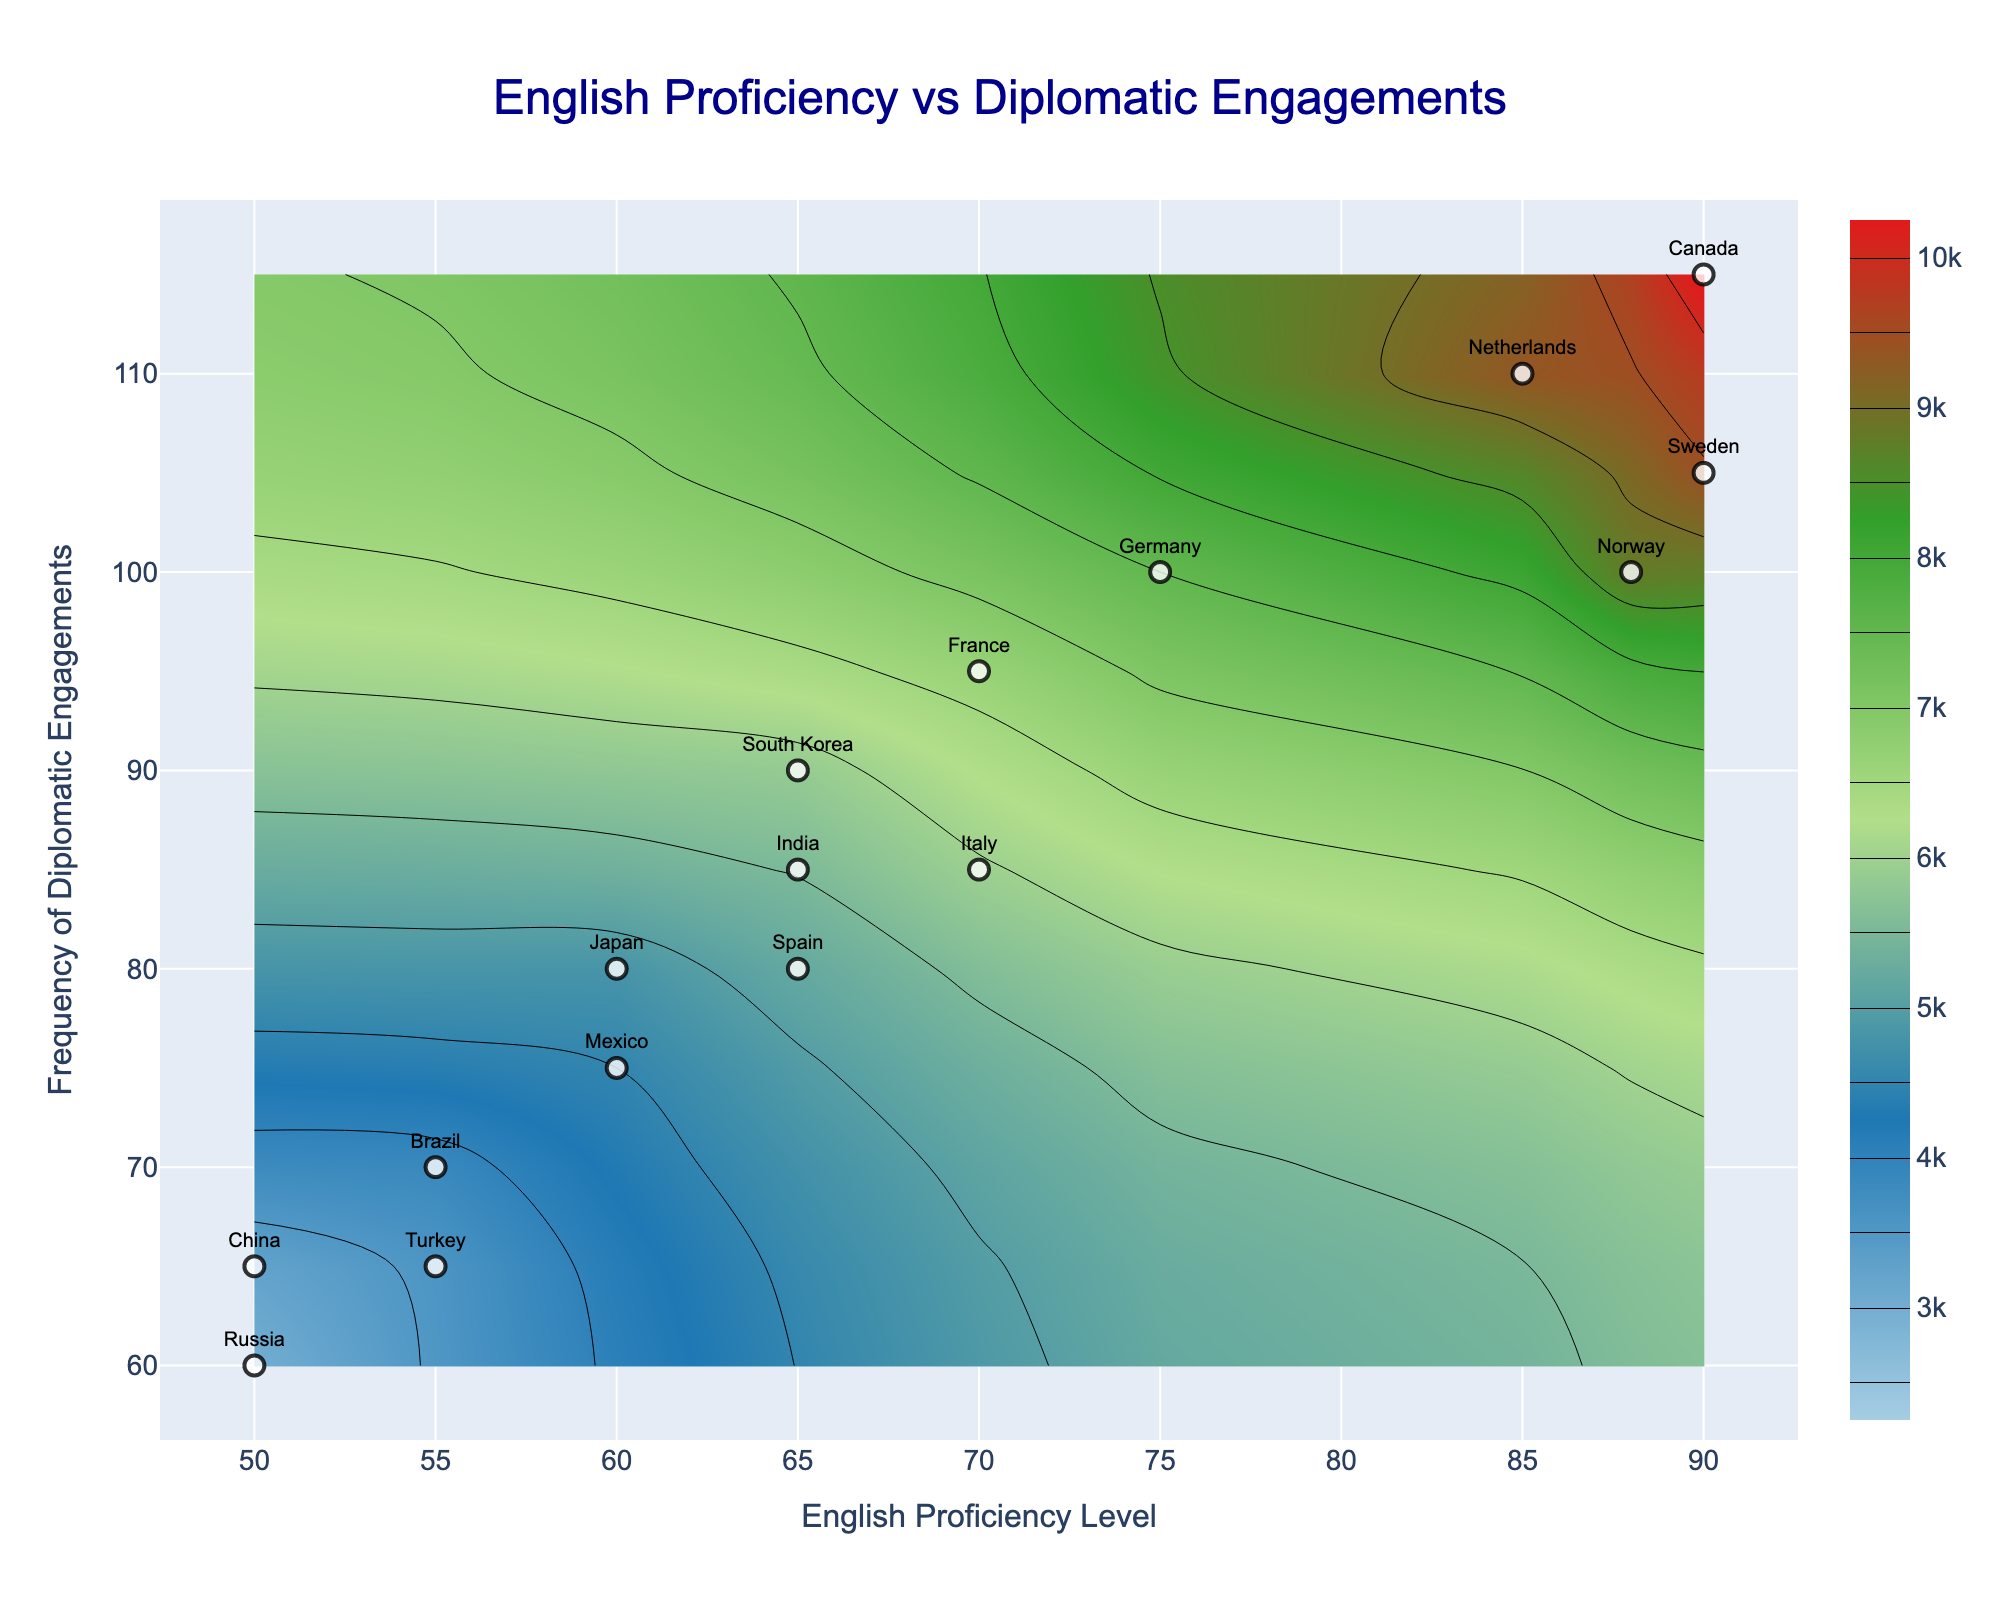What is the title of the plot? The title of the plot is prominently displayed at the top center of the figure. It reads "English Proficiency vs Diplomatic Engagements".
Answer: English Proficiency vs Diplomatic Engagements What are the labels of the x and y axes? The x-axis is labeled as "English Proficiency Level" and the y-axis is labeled as "Frequency of Diplomatic Engagements".
Answer: English Proficiency Level and Frequency of Diplomatic Engagements How many countries are represented in the plot? We can count the number of labeled points in the scatter plot to determine the number of countries. Each country is marked with its name at the corresponding data point. There are 16 countries plotted.
Answer: 16 Which country has the highest English proficiency level? By looking at the data points scattered along the x-axis, the country with the maximum value, which is 90, is Canada.
Answer: Canada Which country has the lowest frequency of diplomatic engagements? By examining the y-axis, the country with the minimum value of 60 is Russia.
Answer: Russia Of the countries plotted, which country has the highest proficiency in English and frequency of diplomatic engagements combined? By finding the country that has the highest values on both axes, Canada stands out with a proficiency level of 90 and 115 diplomatic engagements.
Answer: Canada What is the relationship between English proficiency and frequency of diplomatic engagements for Germany? Referring to the position of Germany’s data point in the plot, Germany has an English proficiency level of 75 and a frequency of diplomatic engagements of 100.
Answer: England proficiency: 75, Diplomatic engagements: 100 Is there a noticeable trend between English proficiency and frequency of diplomatic engagements? The contour lines and scatter points tend to show that with increasing English proficiency levels, there is generally an increase in the frequency of diplomatic engagements.
Answer: Positive trend Which two countries have the same English proficiency level but different frequencies of diplomatic engagements? By comparing data points, Italy and France both have an English proficiency level of 70, but Italy has a frequency of 85 while France has 95.
Answer: Italy and France 